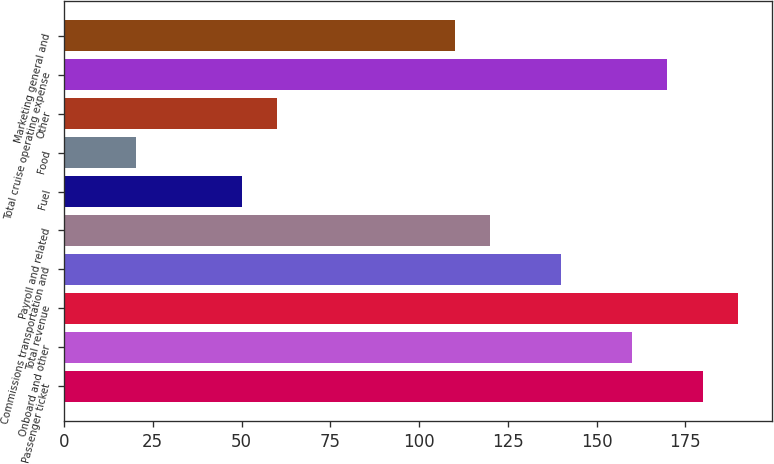<chart> <loc_0><loc_0><loc_500><loc_500><bar_chart><fcel>Passenger ticket<fcel>Onboard and other<fcel>Total revenue<fcel>Commissions transportation and<fcel>Payroll and related<fcel>Fuel<fcel>Food<fcel>Other<fcel>Total cruise operating expense<fcel>Marketing general and<nl><fcel>179.84<fcel>159.88<fcel>189.82<fcel>139.92<fcel>119.96<fcel>50.1<fcel>20.16<fcel>60.08<fcel>169.86<fcel>109.98<nl></chart> 